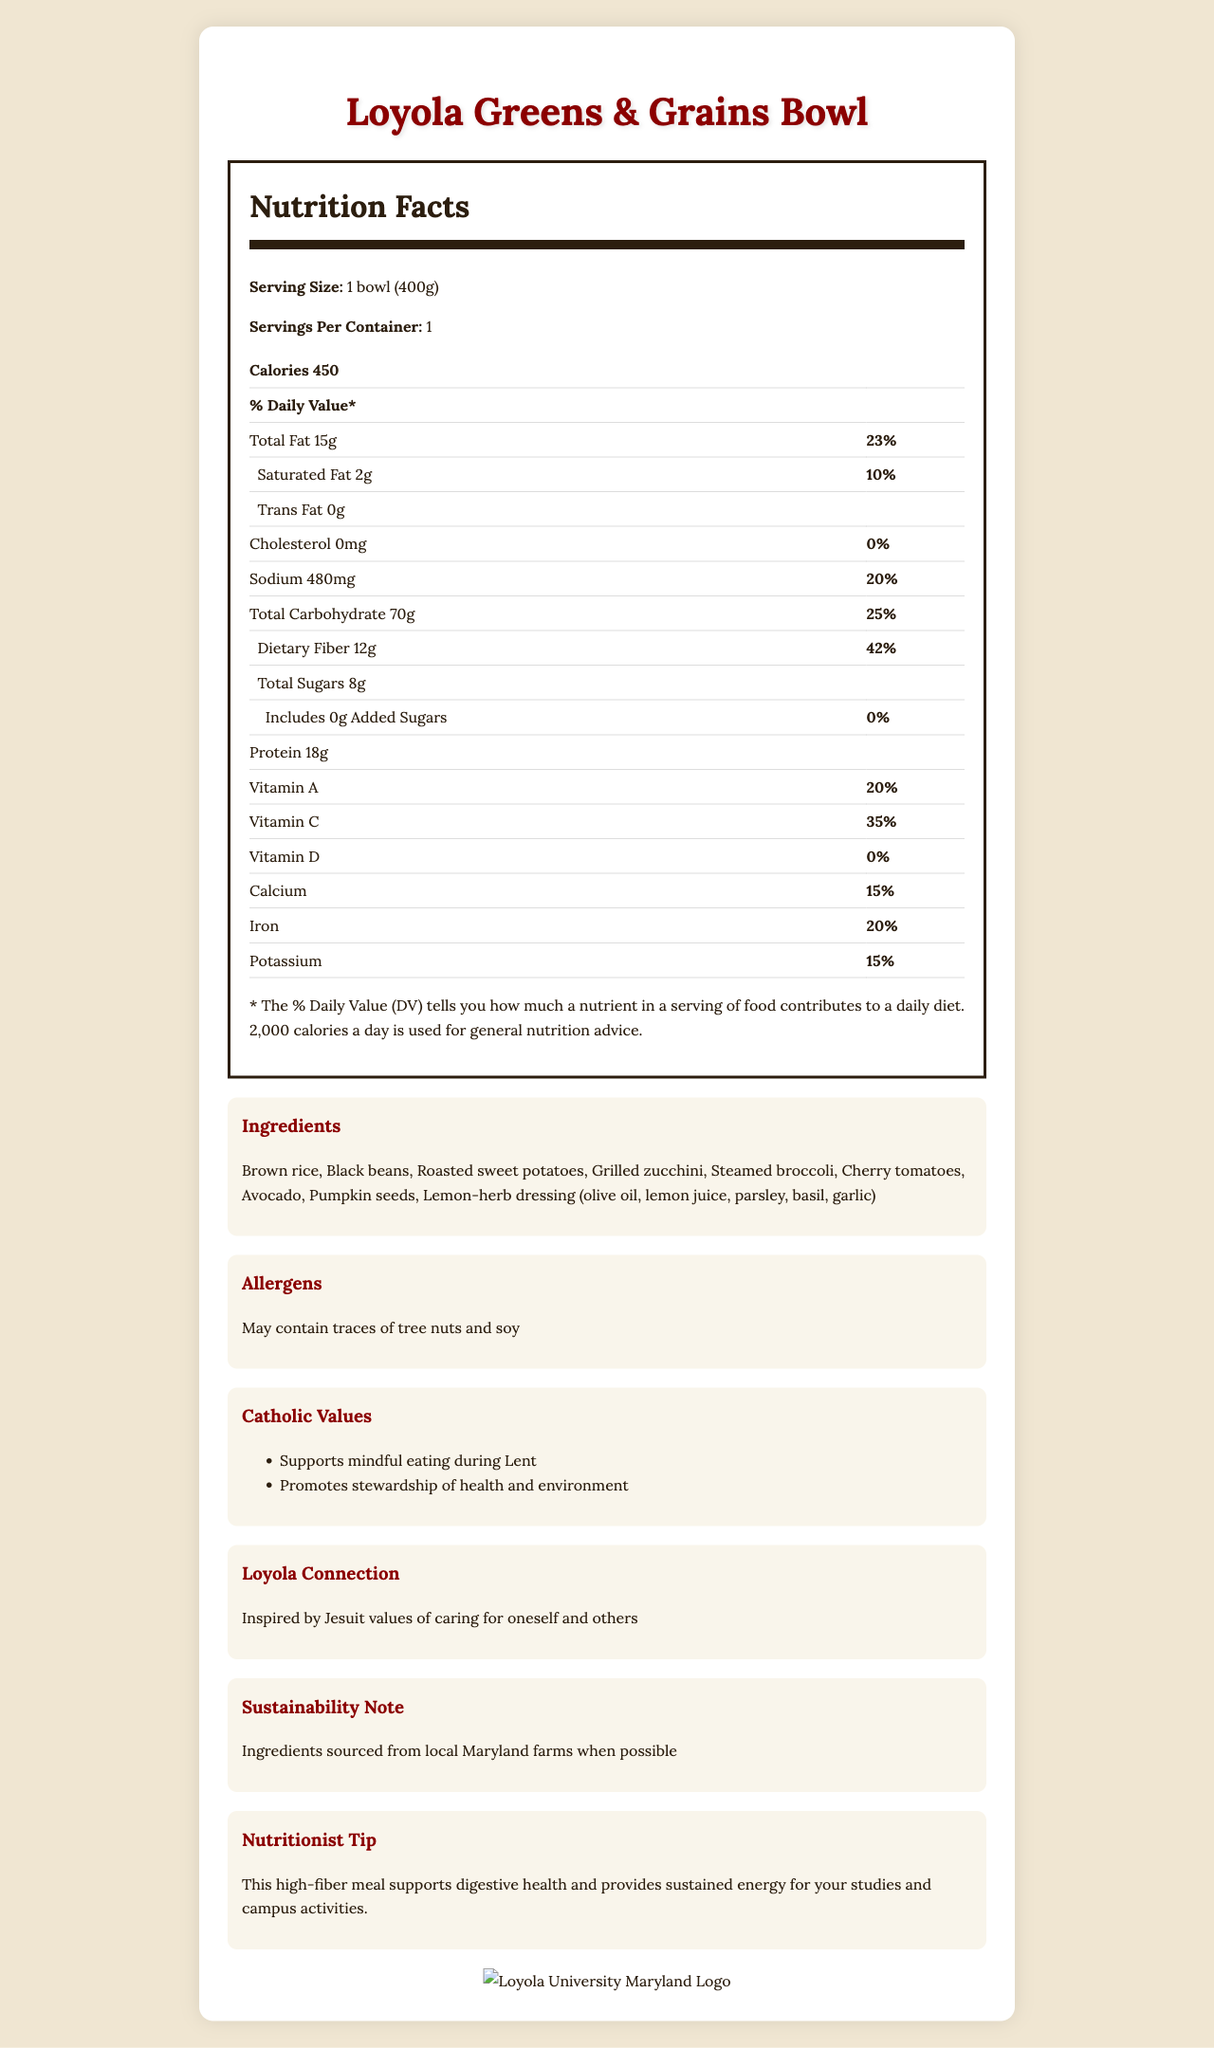what is the serving size of the Loyola Greens & Grains Bowl? The serving size is clearly mentioned in the Nutrition Facts section.
Answer: 1 bowl (400g) how many grams of dietary fiber are in one serving? The Nutrition Facts section lists Dietary Fiber as 12 grams per serving.
Answer: 12 grams What percentage of the daily value for Vitamin C does the Loyola Greens & Grains Bowl provide? The Nutrition Facts section states that the bowl provides 35% of the daily value for Vitamin C.
Answer: 35% Name three ingredients found in the Loyola Greens & Grains Bowl. The Ingredients section lists all the ingredients, including these three.
Answer: Brown rice, Black beans, Roasted sweet potatoes What allergens may be present in the Loyola Greens & Grains Bowl? The Allergens section indicates that the product may contain traces of tree nuts and soy.
Answer: Tree nuts and soy The Loyola Greens & Grains Bowl is a suitable option for which religious observance? A. Ramadan B. Diwali C. Lent D. Hanukkah The Catholic Values section mentions that the bowl supports mindful eating during Lent.
Answer: C. Lent What is the percentage of the daily value for total carbohydrate in one serving? A. 25% B. 30% C. 35% D. 40% The Nutrition Facts section lists the total carbohydrate as 70g, which is 30% of the daily value.
Answer: B. 30% Does the dish contain any added sugars? The Nutrition Facts section lists 0 grams of added sugars.
Answer: No Summarize the main idea of the document. The document includes a thorough breakdown of nutrition information, the ingredient list, allergen information, Catholic values, Loyola University's connection to the product, and a sustainability note. It also includes a nutritionist tip.
Answer: The document provides the nutrition facts, ingredients, and various notes related to the Loyola Greens & Grains Bowl, emphasizing its health benefits, alignment with Catholic values, and local sustainability efforts. How is the Loyola Greens & Grains Bowl connected to Loyola University Maryland's values? The Loyola Connection section mentions that the bowl is inspired by Jesuit values of caring for oneself and others.
Answer: Inspired by Jesuit values of caring for oneself and others How many grams of protein are in one serving of the bowl? The Nutrition Facts section shows that the bowl contains 18 grams of protein per serving.
Answer: 18 grams Is the ingredient sourcing for the Loyola Greens & Grains Bowl focused on sustainability? The Sustainability Note section mentions that the ingredients are sourced from local Maryland farms when possible.
Answer: Yes What would be the % daily value of sodium if the serving size was doubled? The current % daily value for sodium is 21% for a single serving (480mg). If the serving size is doubled to 960mg of sodium, the % daily value would be double, i.e., 42%.
Answer: 42% What is the recommended daily calorie intake used for the general nutrition advice in the Nutrition Facts? The note at the end of the Nutrition Facts section states that 2000 calories a day is used for general nutrition advice.
Answer: 2000 calories Who is likely the target audience for the Nutritionist Tip? The Nutritionist Tip mentions support for digestive health and sustained energy for studies and campus activities, indicating the target audience.
Answer: Loyola College students What are the proportions of vitamins A, C, and D in the bowl? The Nutrition Facts section lists Vitamin A as 20%, Vitamin C as 35%, and Vitamin D as 0%.
Answer: 20%, 35%, 0% What is the main dressing ingredient in the bowl? The Ingredients section lists the lemon-herb dressing, with olive oil as one of its components.
Answer: Olive oil Does the document mention if the protein content is from animal sources? The document only lists the ingredients and the protein amount but does not specify the sources of protein.
Answer: No What is the purpose of the Catholic Values section in the document? The Catholic Values section details the alignment of the dish with Catholic practices and values.
Answer: To highlight how the bowl supports mindful eating during Lent and promotes health and environmental stewardship What is the total fat content in the Loyola Greens & Grains Bowl? The Nutrition Facts section indicates the total fat content as 15 grams.
Answer: 15 grams 